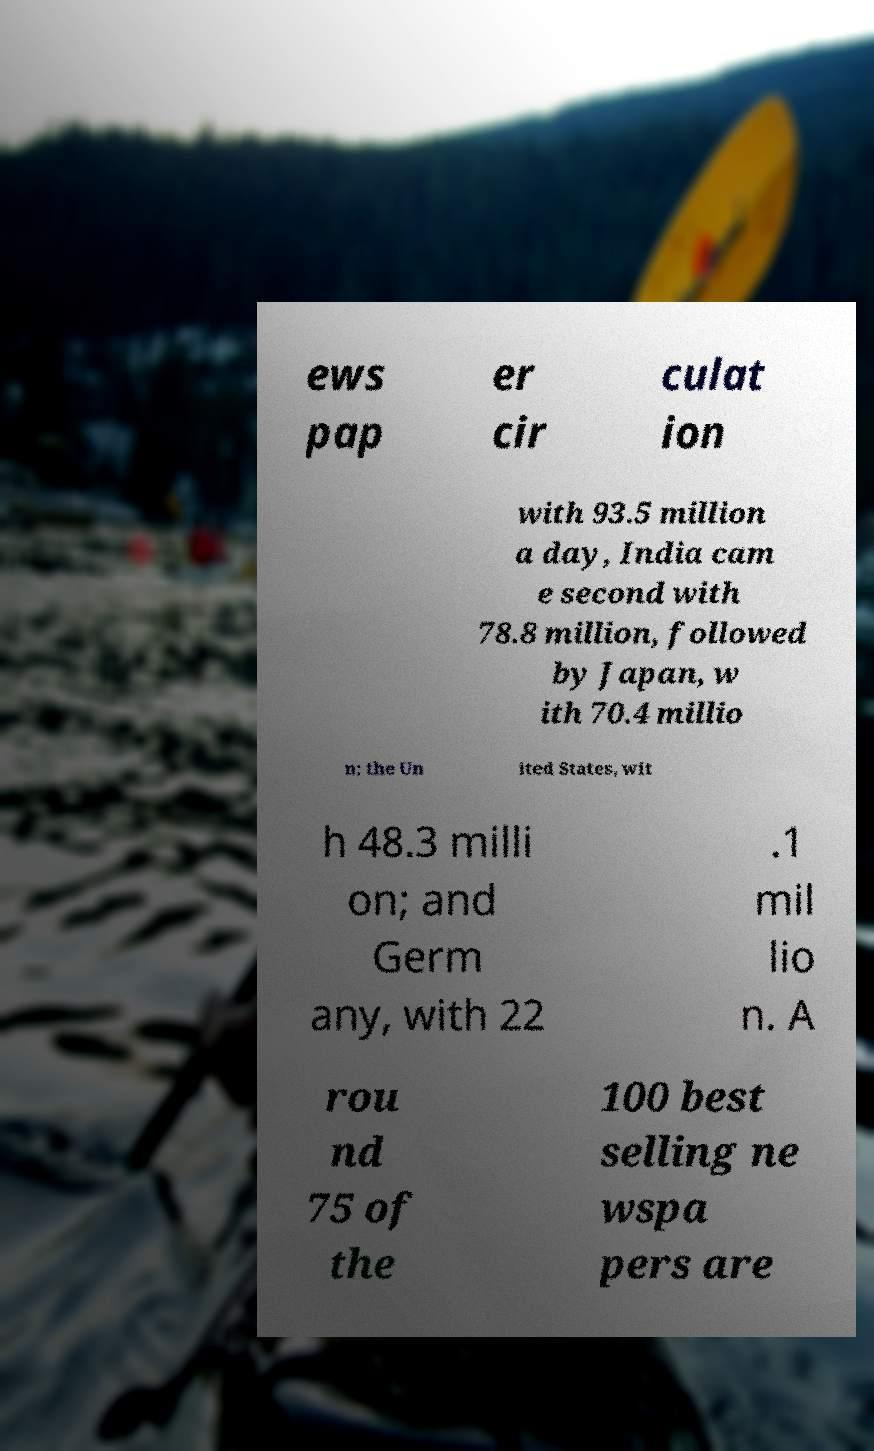Please read and relay the text visible in this image. What does it say? ews pap er cir culat ion with 93.5 million a day, India cam e second with 78.8 million, followed by Japan, w ith 70.4 millio n; the Un ited States, wit h 48.3 milli on; and Germ any, with 22 .1 mil lio n. A rou nd 75 of the 100 best selling ne wspa pers are 